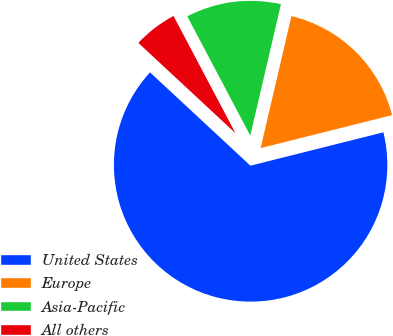Convert chart to OTSL. <chart><loc_0><loc_0><loc_500><loc_500><pie_chart><fcel>United States<fcel>Europe<fcel>Asia-Pacific<fcel>All others<nl><fcel>65.84%<fcel>17.44%<fcel>11.39%<fcel>5.34%<nl></chart> 